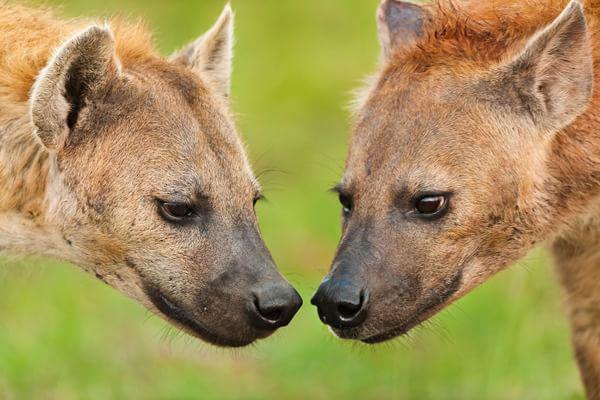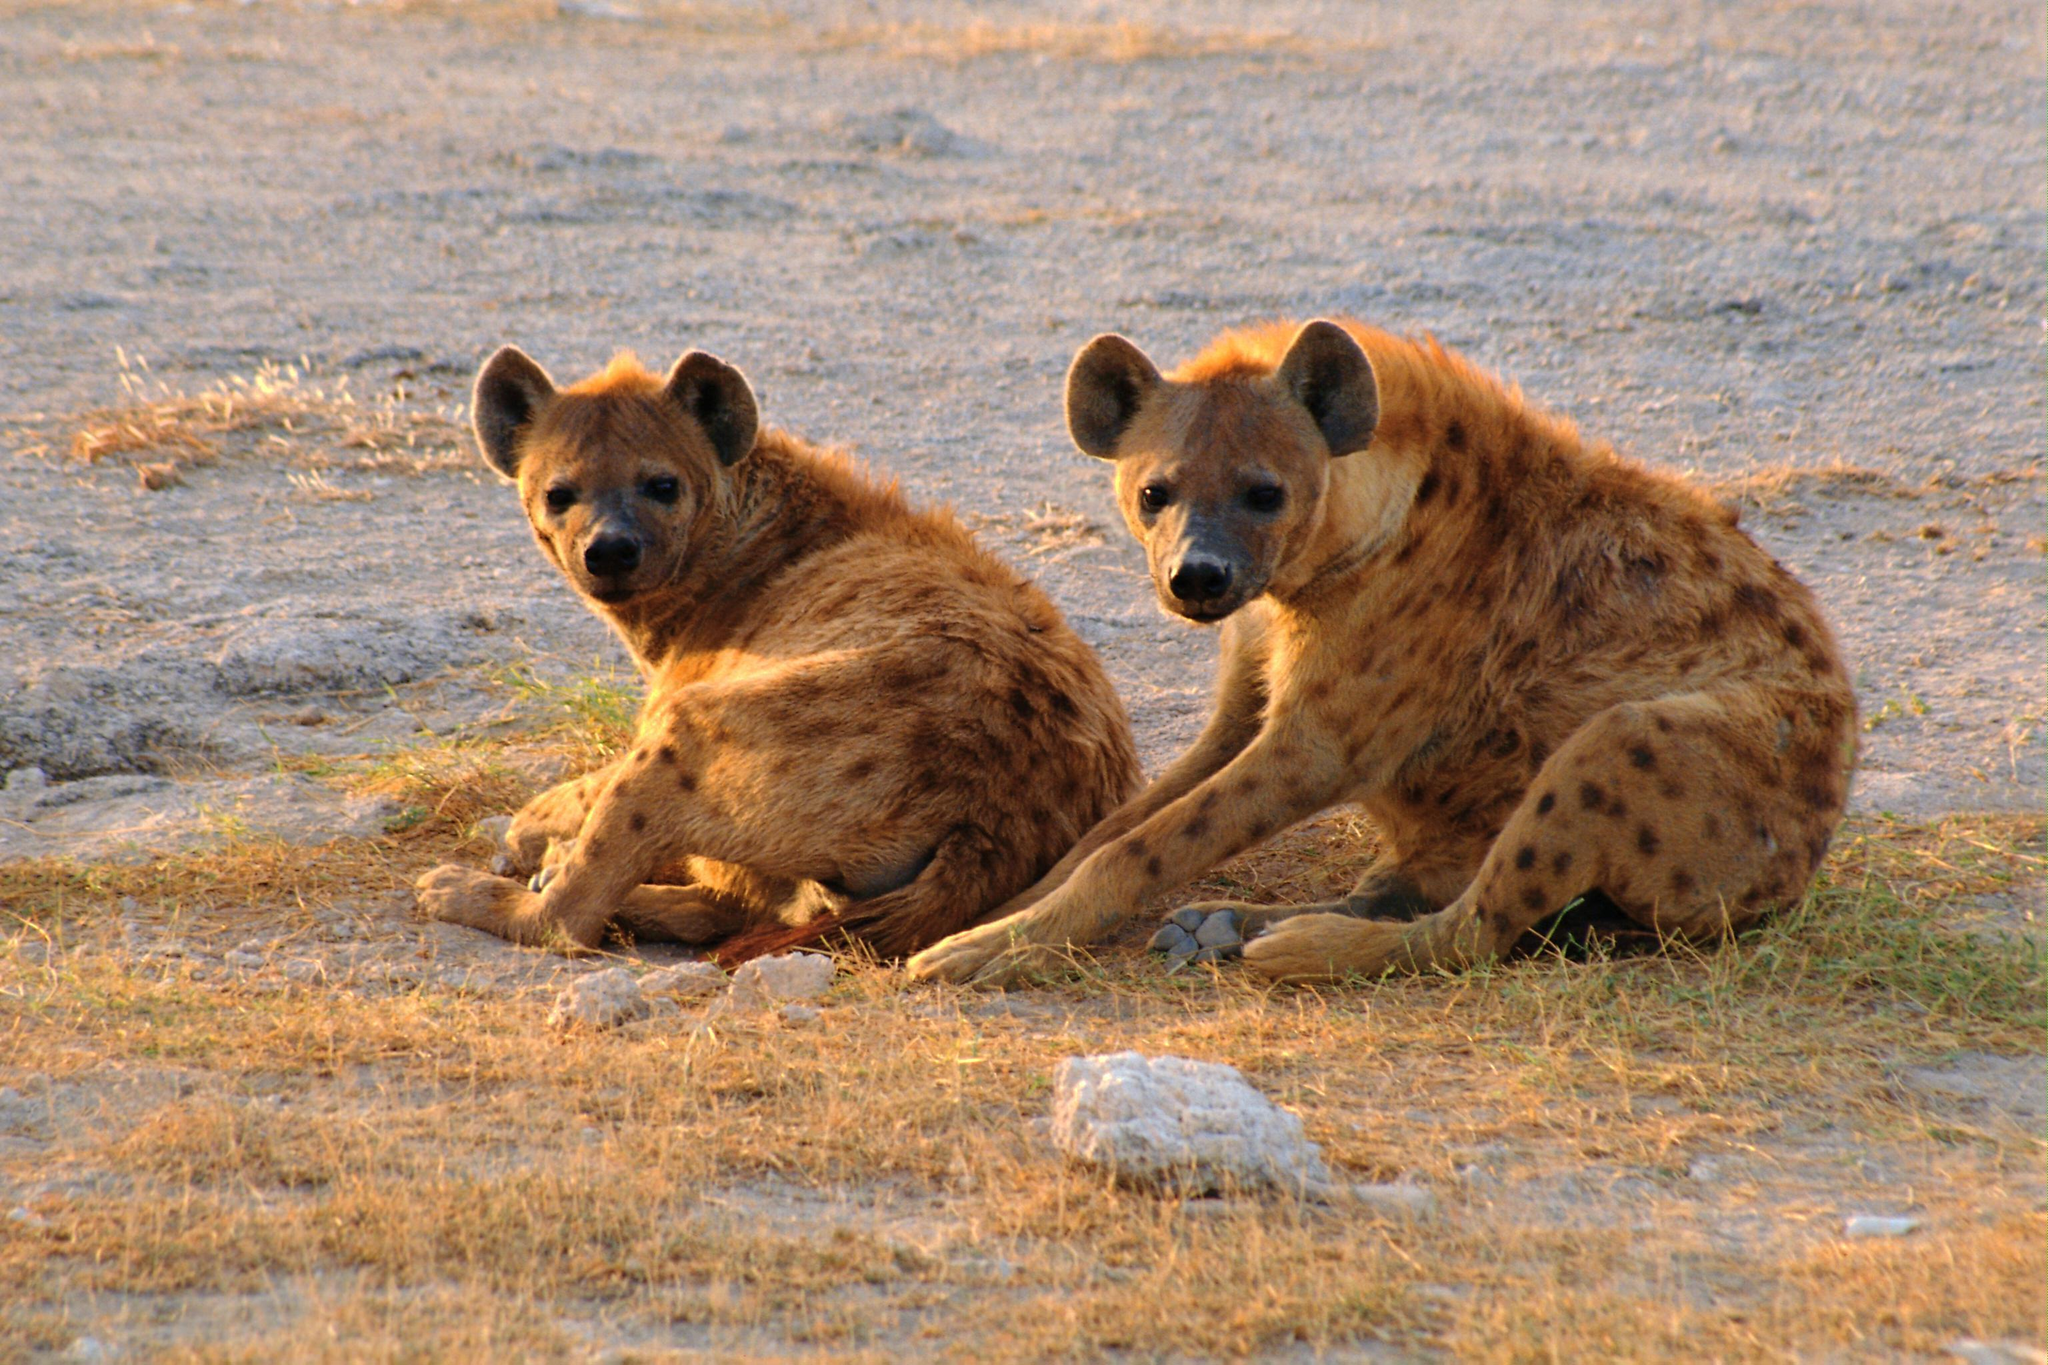The first image is the image on the left, the second image is the image on the right. For the images displayed, is the sentence "One animal is lying down and another is standing in at least one of the images." factually correct? Answer yes or no. No. The first image is the image on the left, the second image is the image on the right. For the images displayed, is the sentence "An image shows two hyenas posed nose to nose, with no carcass between them." factually correct? Answer yes or no. Yes. 